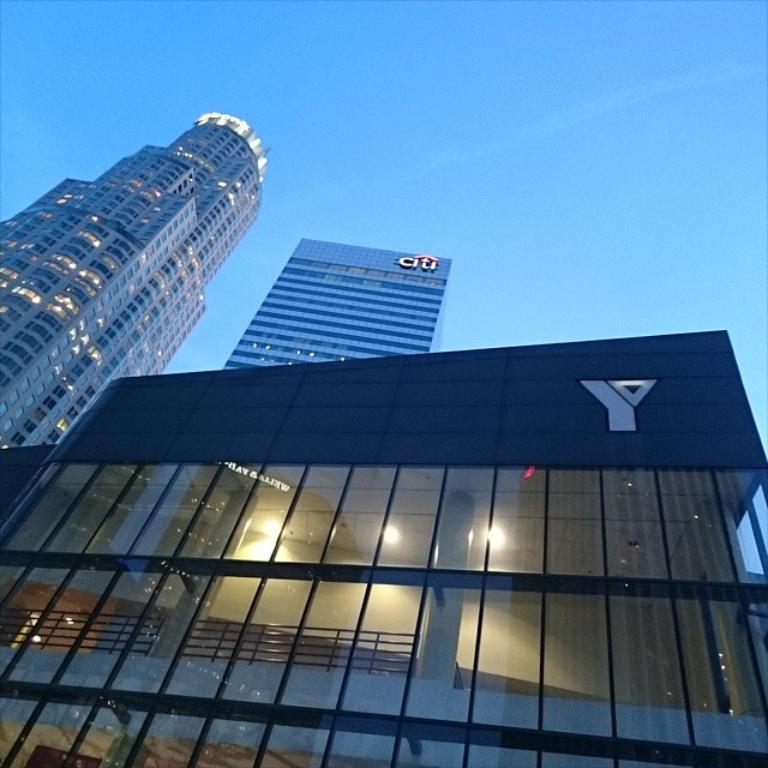What type of structures are depicted in the image? There are very big buildings in the image. What material is used in the construction of the buildings? The buildings have glass in them. What is visible at the top of the image? The sky is visible at the top of the image. How would you describe the weather based on the image? The sky is sunny, suggesting a clear and bright day. What type of instrument is the lawyer playing in the image? There is no lawyer or instrument present in the image. What type of dress is the building wearing in the image? The buildings in the image are not wearing any dress; they are inanimate structures. 